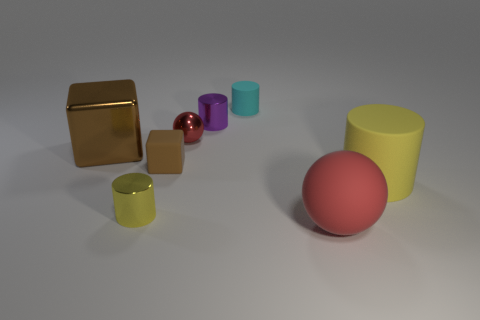Add 1 small metal things. How many objects exist? 9 Subtract all spheres. How many objects are left? 6 Subtract 1 brown cubes. How many objects are left? 7 Subtract all blue shiny things. Subtract all large matte cylinders. How many objects are left? 7 Add 3 rubber cylinders. How many rubber cylinders are left? 5 Add 4 small cyan cylinders. How many small cyan cylinders exist? 5 